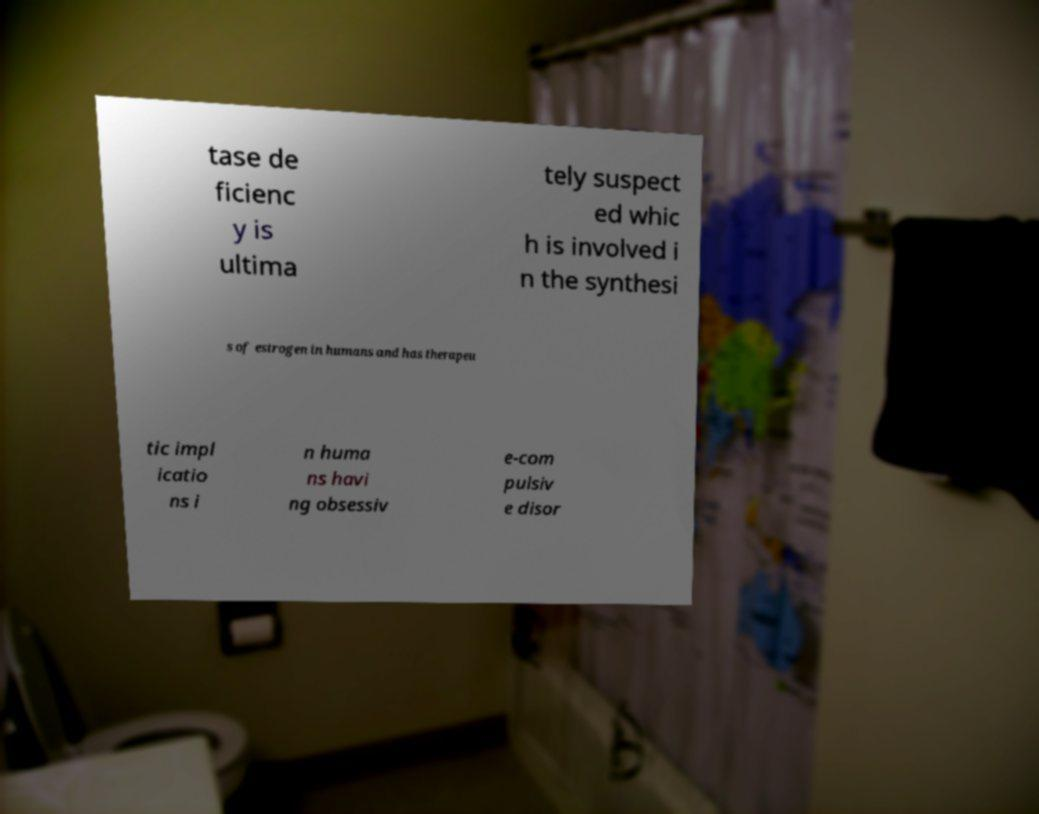What messages or text are displayed in this image? I need them in a readable, typed format. tase de ficienc y is ultima tely suspect ed whic h is involved i n the synthesi s of estrogen in humans and has therapeu tic impl icatio ns i n huma ns havi ng obsessiv e-com pulsiv e disor 